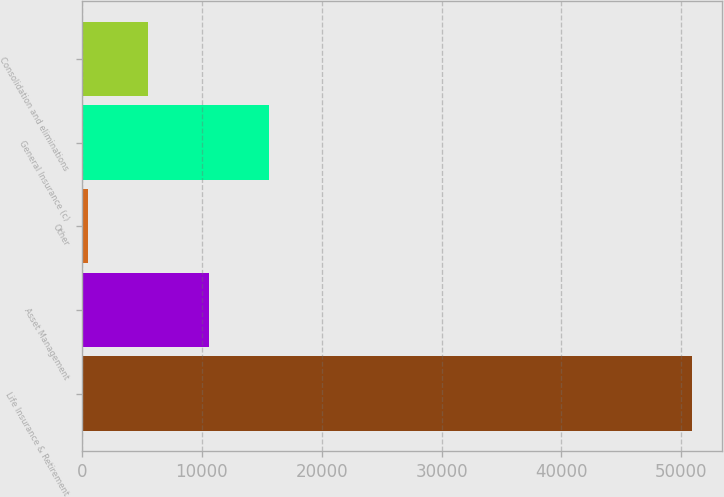Convert chart to OTSL. <chart><loc_0><loc_0><loc_500><loc_500><bar_chart><fcel>Life Insurance & Retirement<fcel>Asset Management<fcel>Other<fcel>General Insurance (c)<fcel>Consolidation and eliminations<nl><fcel>50878<fcel>10562<fcel>483<fcel>15601.5<fcel>5522.5<nl></chart> 